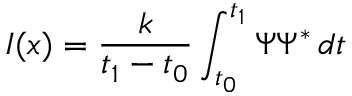Convert formula to latex. <formula><loc_0><loc_0><loc_500><loc_500>I ( x ) = { \frac { k } { t _ { 1 } - t _ { 0 } } } \int _ { t _ { 0 } } ^ { t _ { 1 } } \Psi \Psi ^ { * } \, d t</formula> 